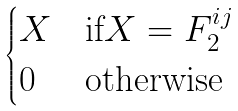Convert formula to latex. <formula><loc_0><loc_0><loc_500><loc_500>\begin{cases} X & \text {if} X = F _ { 2 } ^ { i j } \\ 0 & \text {otherwise} \end{cases}</formula> 